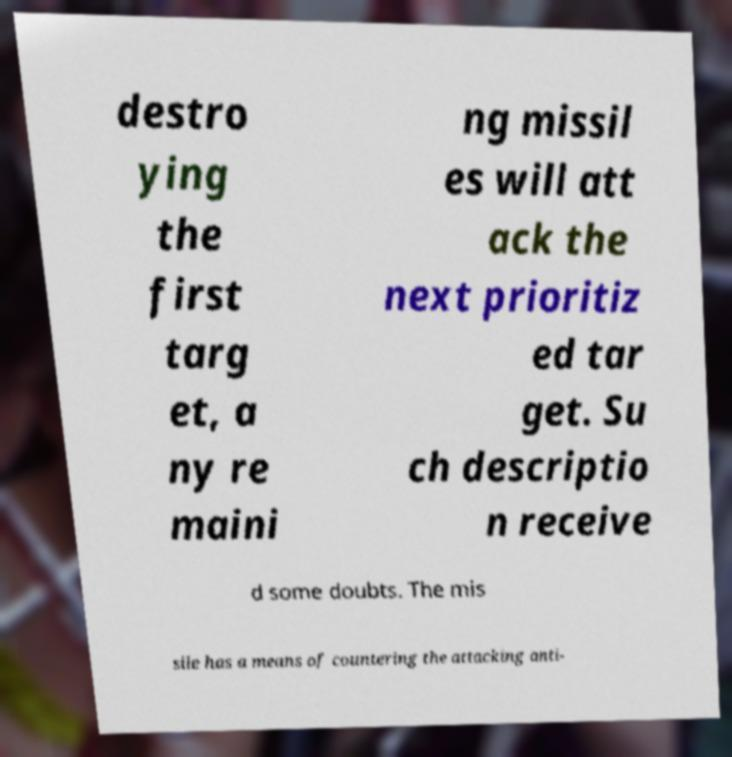Please identify and transcribe the text found in this image. destro ying the first targ et, a ny re maini ng missil es will att ack the next prioritiz ed tar get. Su ch descriptio n receive d some doubts. The mis sile has a means of countering the attacking anti- 